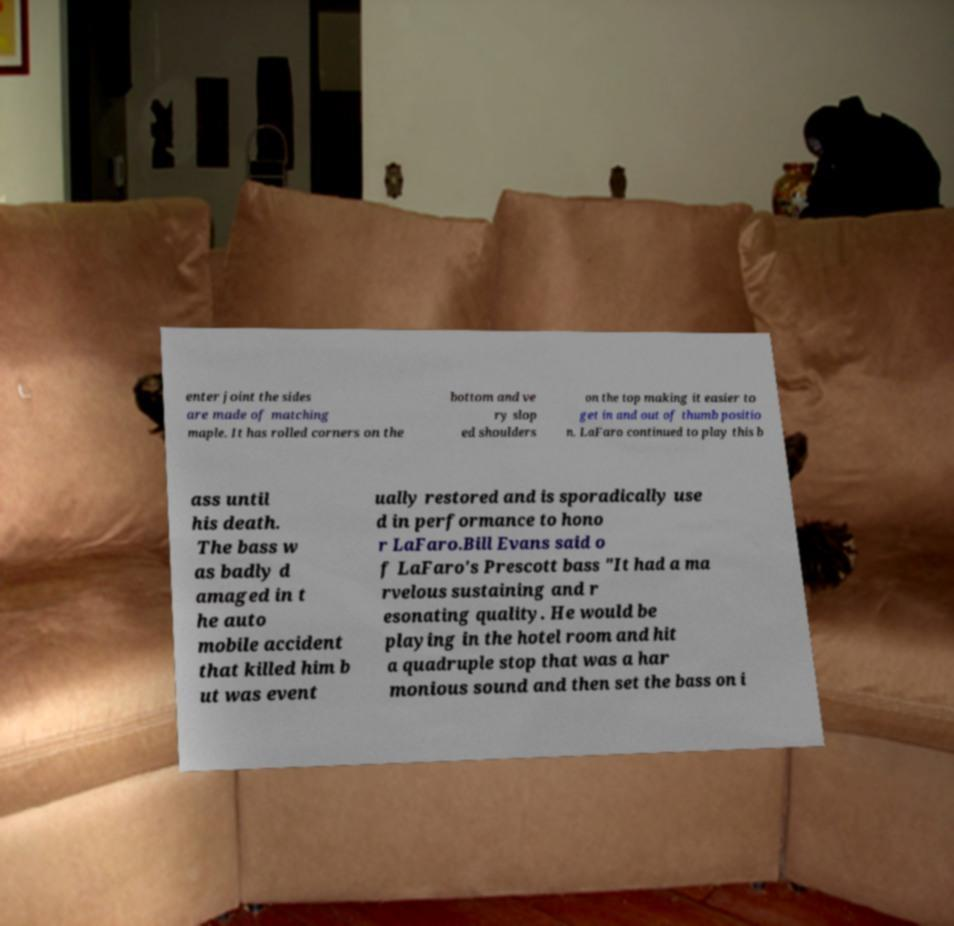Please read and relay the text visible in this image. What does it say? enter joint the sides are made of matching maple. It has rolled corners on the bottom and ve ry slop ed shoulders on the top making it easier to get in and out of thumb positio n. LaFaro continued to play this b ass until his death. The bass w as badly d amaged in t he auto mobile accident that killed him b ut was event ually restored and is sporadically use d in performance to hono r LaFaro.Bill Evans said o f LaFaro's Prescott bass "It had a ma rvelous sustaining and r esonating quality. He would be playing in the hotel room and hit a quadruple stop that was a har monious sound and then set the bass on i 